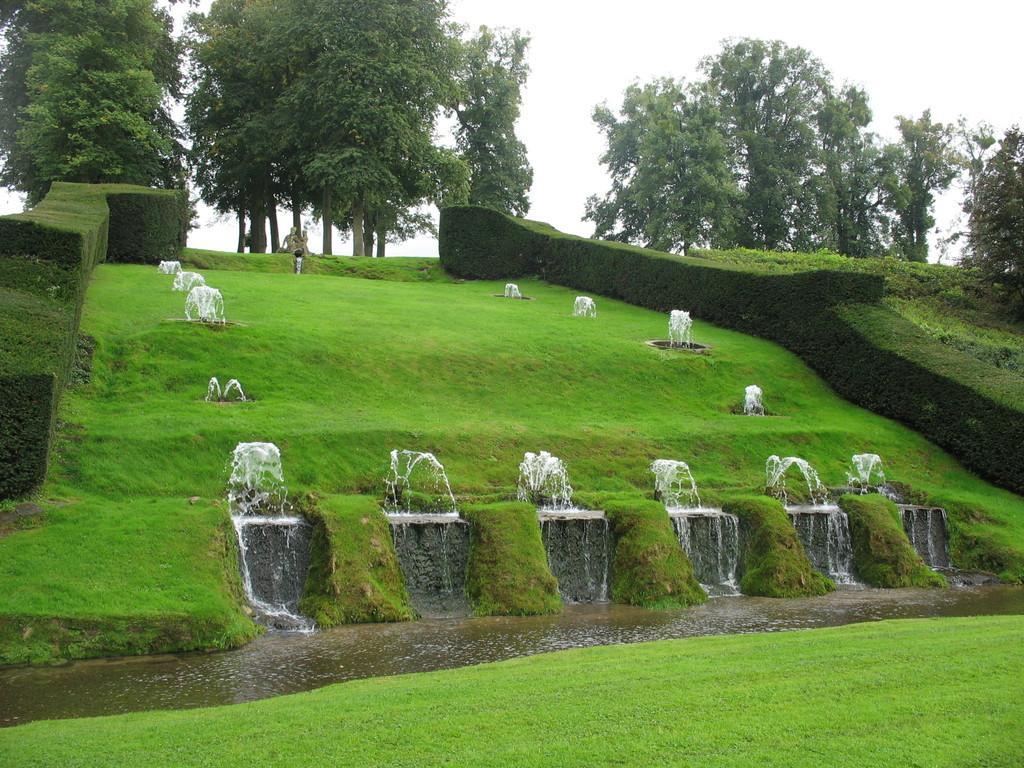Could you give a brief overview of what you see in this image? In this picture we can see water, grass, shrubs and few trees. 